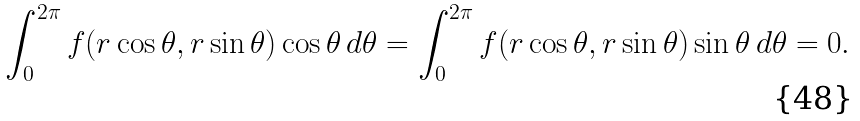<formula> <loc_0><loc_0><loc_500><loc_500>\int _ { 0 } ^ { 2 \pi } f ( r \cos \theta , r \sin \theta ) \cos \theta \, d \theta = \int _ { 0 } ^ { 2 \pi } f ( r \cos \theta , r \sin \theta ) \sin \theta \, d \theta = 0 .</formula> 